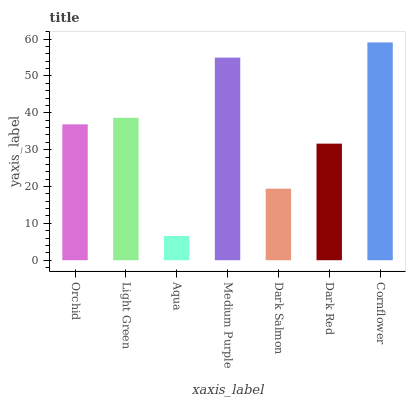Is Light Green the minimum?
Answer yes or no. No. Is Light Green the maximum?
Answer yes or no. No. Is Light Green greater than Orchid?
Answer yes or no. Yes. Is Orchid less than Light Green?
Answer yes or no. Yes. Is Orchid greater than Light Green?
Answer yes or no. No. Is Light Green less than Orchid?
Answer yes or no. No. Is Orchid the high median?
Answer yes or no. Yes. Is Orchid the low median?
Answer yes or no. Yes. Is Aqua the high median?
Answer yes or no. No. Is Aqua the low median?
Answer yes or no. No. 